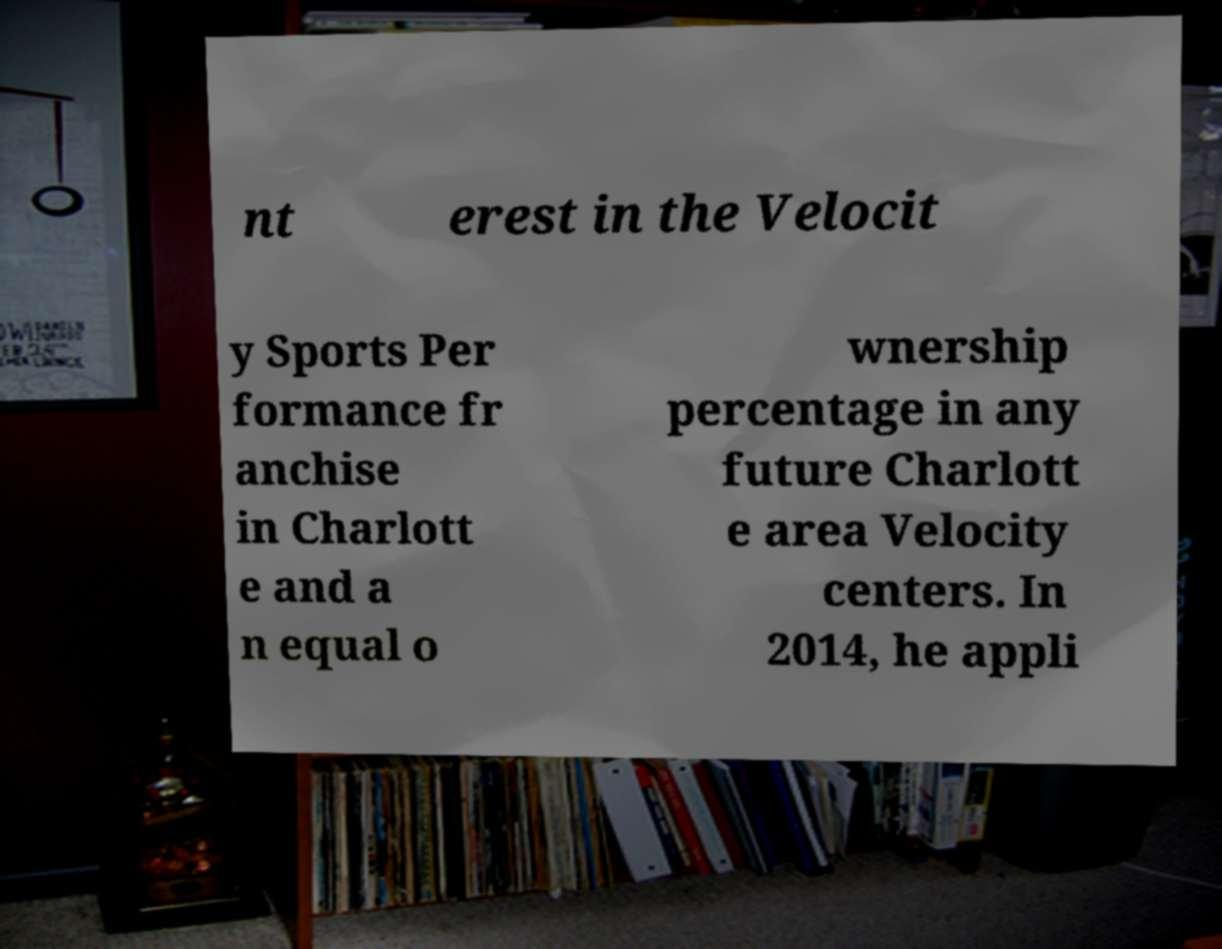Could you assist in decoding the text presented in this image and type it out clearly? nt erest in the Velocit y Sports Per formance fr anchise in Charlott e and a n equal o wnership percentage in any future Charlott e area Velocity centers. In 2014, he appli 